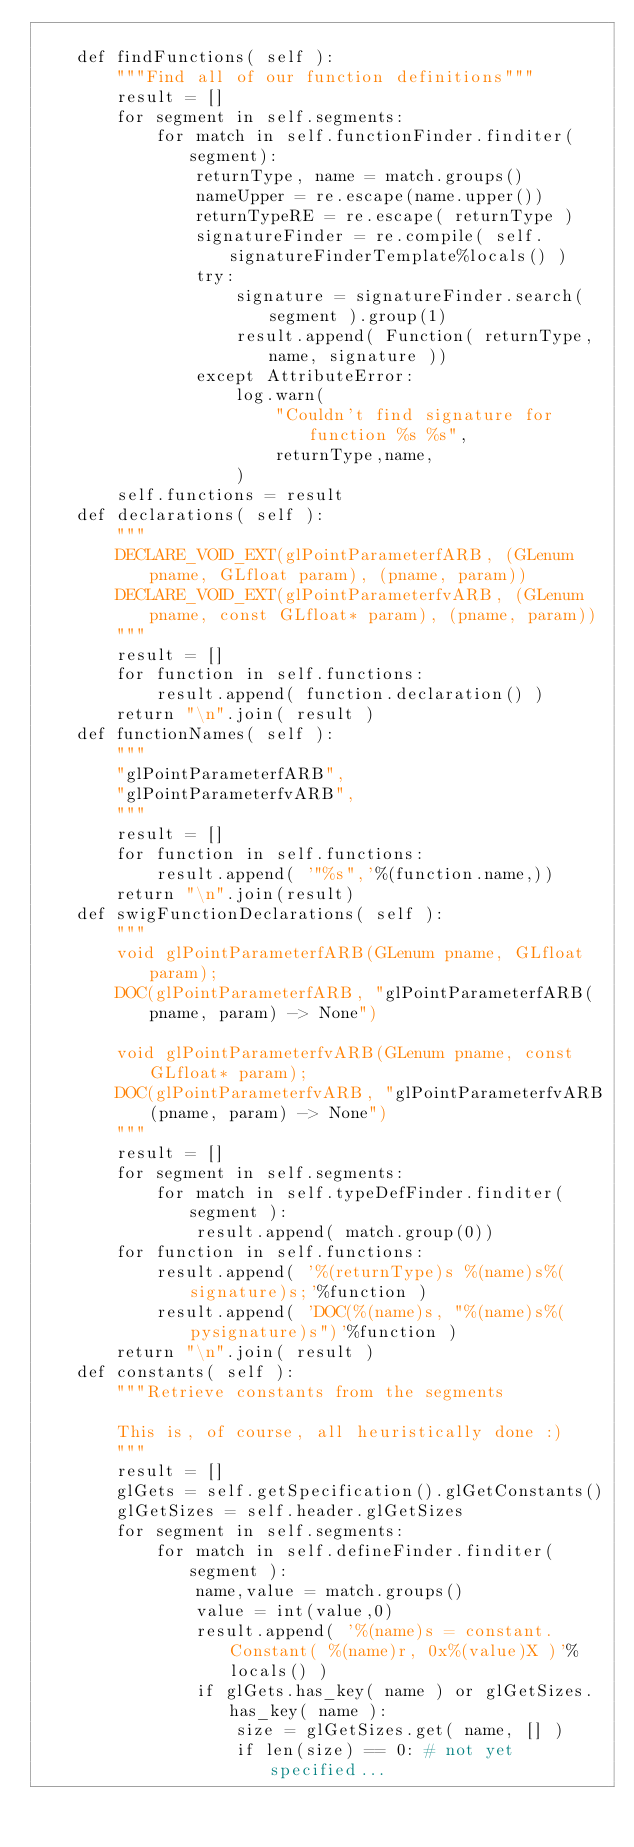<code> <loc_0><loc_0><loc_500><loc_500><_Python_>
    def findFunctions( self ):
        """Find all of our function definitions"""
        result = []
        for segment in self.segments:
            for match in self.functionFinder.finditer(segment):
                returnType, name = match.groups()
                nameUpper = re.escape(name.upper())
                returnTypeRE = re.escape( returnType )
                signatureFinder = re.compile( self.signatureFinderTemplate%locals() )
                try:
                    signature = signatureFinder.search( segment ).group(1)
                    result.append( Function( returnType, name, signature ))
                except AttributeError:
                    log.warn( 
                        "Couldn't find signature for function %s %s",
                        returnType,name,
                    )
        self.functions = result
    def declarations( self ):
        """
        DECLARE_VOID_EXT(glPointParameterfARB, (GLenum pname, GLfloat param), (pname, param))
        DECLARE_VOID_EXT(glPointParameterfvARB, (GLenum pname, const GLfloat* param), (pname, param))
        """
        result = []
        for function in self.functions:
            result.append( function.declaration() )
        return "\n".join( result )
    def functionNames( self ):
        """
        "glPointParameterfARB",
        "glPointParameterfvARB",
        """
        result = []
        for function in self.functions:
            result.append( '"%s",'%(function.name,))
        return "\n".join(result)
    def swigFunctionDeclarations( self ):
        """
        void glPointParameterfARB(GLenum pname, GLfloat param);
        DOC(glPointParameterfARB, "glPointParameterfARB(pname, param) -> None")

        void glPointParameterfvARB(GLenum pname, const GLfloat* param);
        DOC(glPointParameterfvARB, "glPointParameterfvARB(pname, param) -> None")
        """
        result = []
        for segment in self.segments:
            for match in self.typeDefFinder.finditer( segment ):
                result.append( match.group(0))
        for function in self.functions:
            result.append( '%(returnType)s %(name)s%(signature)s;'%function )
            result.append( 'DOC(%(name)s, "%(name)s%(pysignature)s")'%function )
        return "\n".join( result )
    def constants( self ):
        """Retrieve constants from the segments

        This is, of course, all heuristically done :)
        """
        result = []
        glGets = self.getSpecification().glGetConstants()
        glGetSizes = self.header.glGetSizes
        for segment in self.segments:
            for match in self.defineFinder.finditer( segment ):
                name,value = match.groups()
                value = int(value,0)
                result.append( '%(name)s = constant.Constant( %(name)r, 0x%(value)X )'%locals() )
                if glGets.has_key( name ) or glGetSizes.has_key( name ):
                    size = glGetSizes.get( name, [] )
                    if len(size) == 0: # not yet specified...</code> 